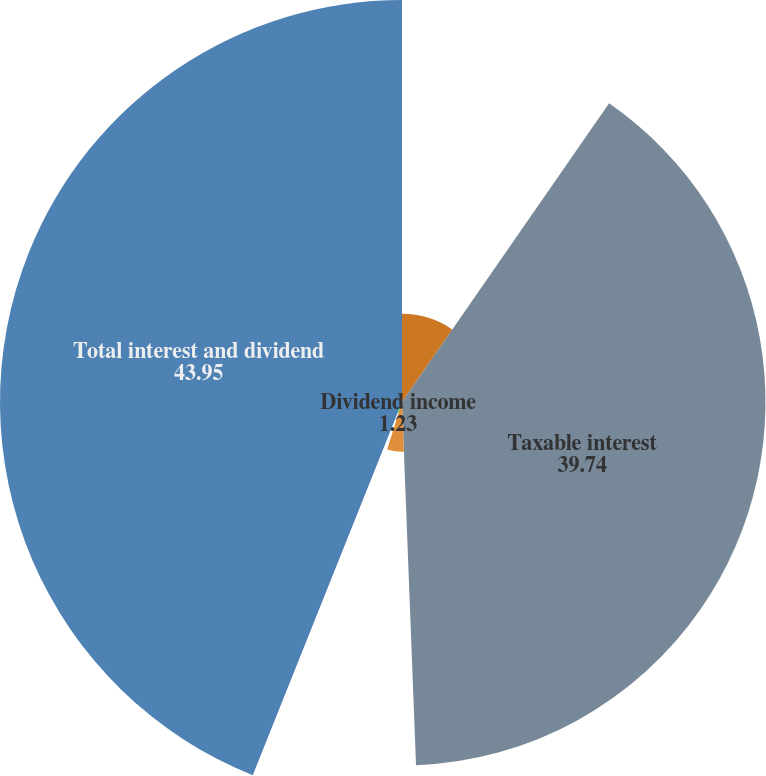<chart> <loc_0><loc_0><loc_500><loc_500><pie_chart><fcel>In millions of dollars<fcel>Taxable interest<fcel>Interest exempt from US<fcel>Dividend income<fcel>Total interest and dividend<nl><fcel>9.65%<fcel>39.74%<fcel>5.44%<fcel>1.23%<fcel>43.95%<nl></chart> 